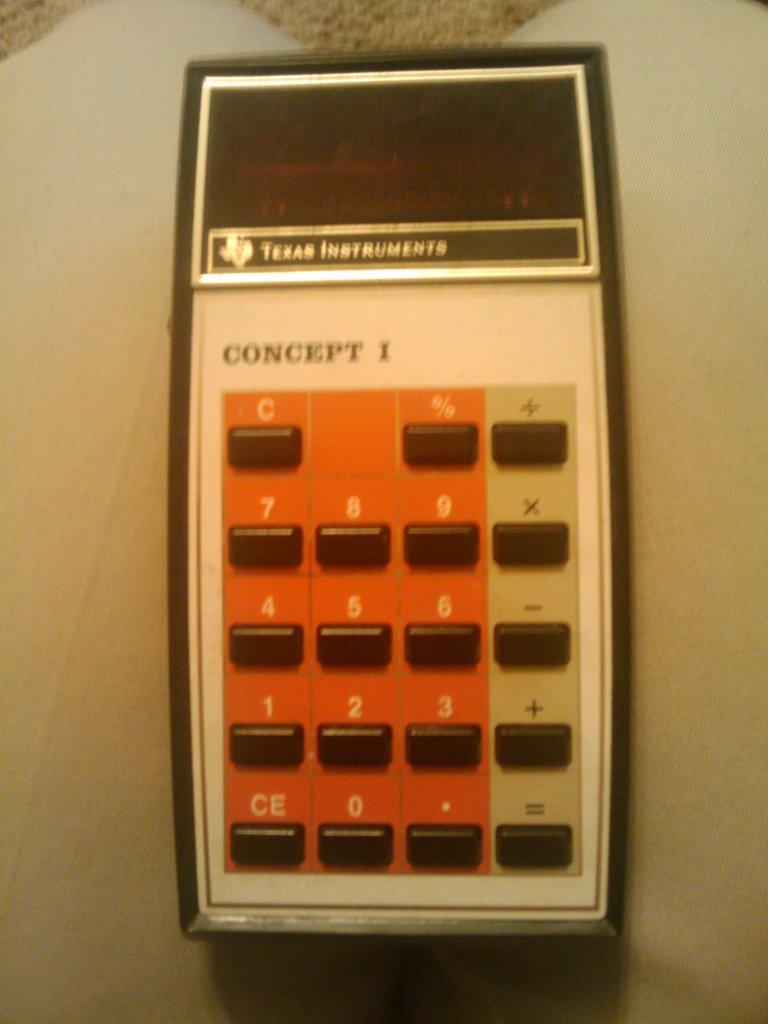<image>
Render a clear and concise summary of the photo. A concept calculator sits on the grey floor 